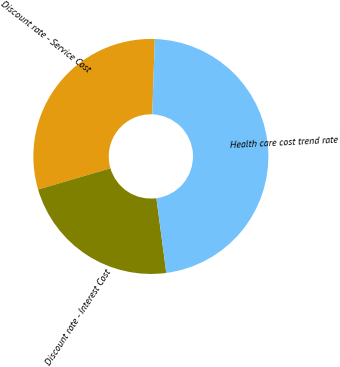Convert chart. <chart><loc_0><loc_0><loc_500><loc_500><pie_chart><fcel>Discount rate - Service Cost<fcel>Discount rate - Interest Cost<fcel>Health care cost trend rate<nl><fcel>30.08%<fcel>22.56%<fcel>47.37%<nl></chart> 